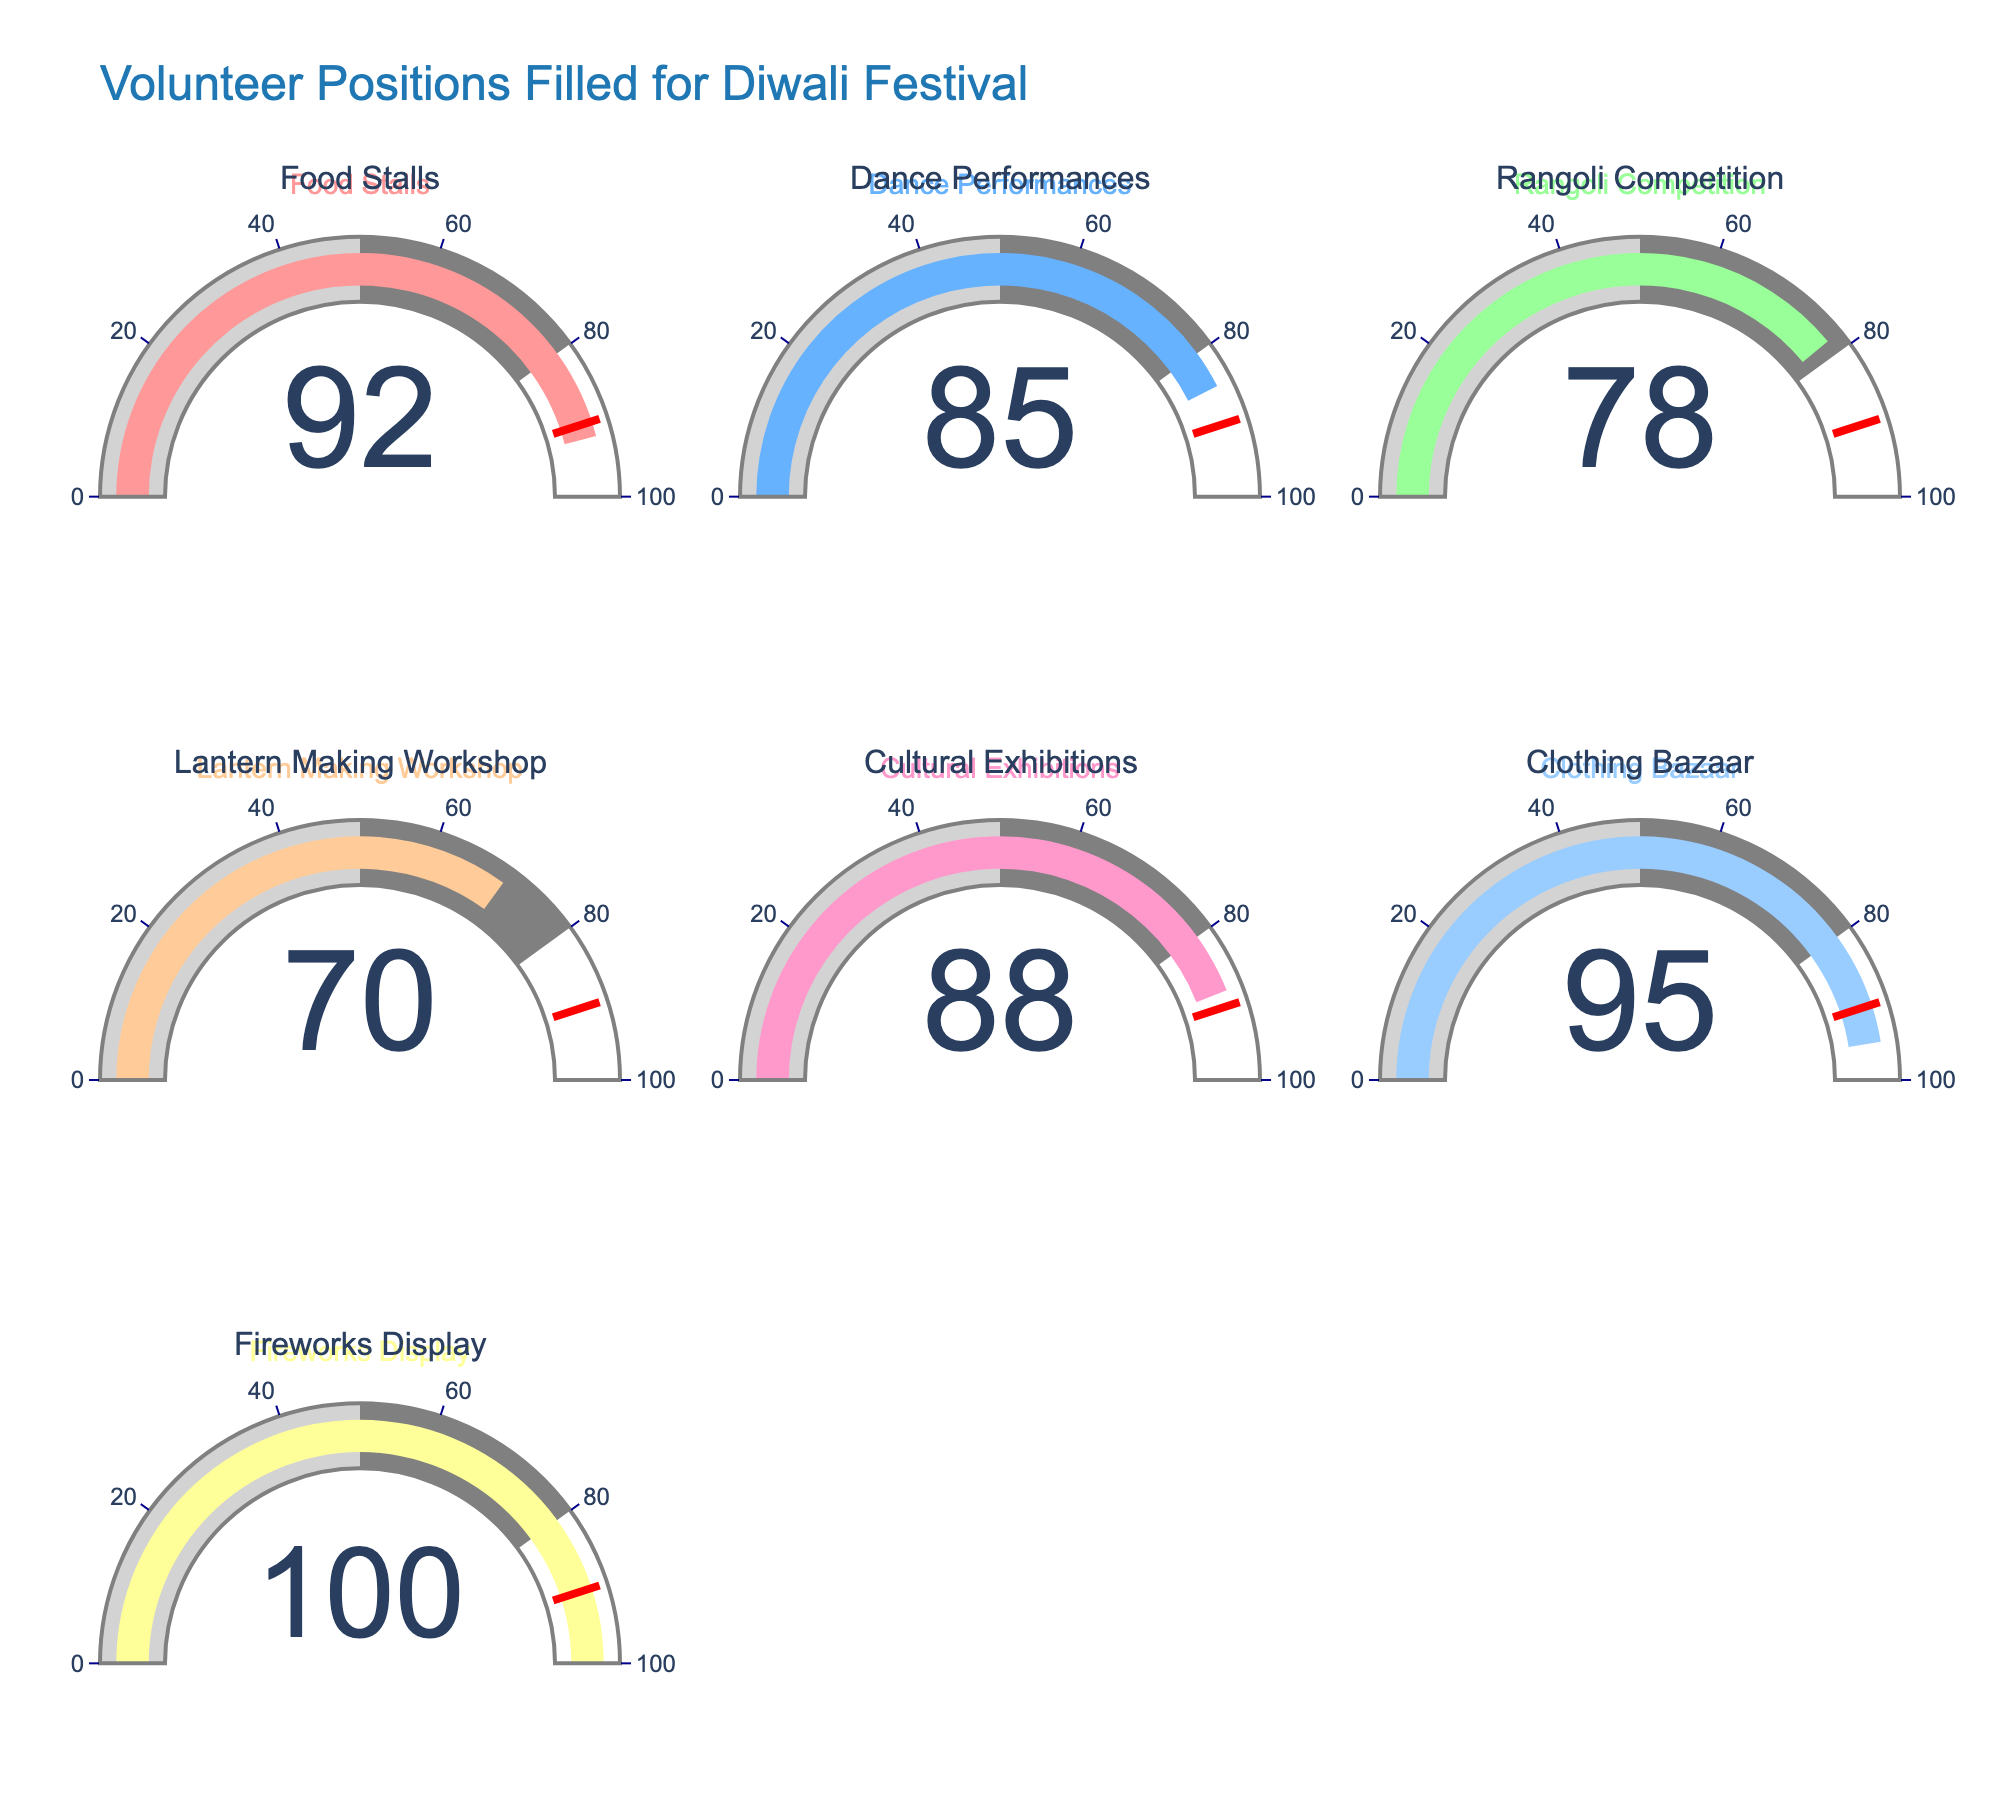What percentage of volunteer positions are filled for the Cultural Exhibitions? The figure shows a gauge for each category. The gauge for Cultural Exhibitions indicates 88%.
Answer: 88% Which event has the highest percentage of volunteer positions filled? By examining each gauge, the Fireworks Display has the highest percentage filled at 100%.
Answer: Fireworks Display What is the total percentage of volunteer positions filled for the Food Stalls and Dance Performances? The percentage for Food Stalls is 92% and for Dance Performances is 85%. Adding them together: 92 + 85 = 177%.
Answer: 177% Are there any events with volunteer positions filled above 90%? If so, which ones? The events with 90% or higher are Food Stalls (92%), Clothing Bazaar (95%), and Fireworks Display (100%).
Answer: Food Stalls, Clothing Bazaar, Fireworks Display What is the average percentage of volunteer positions filled across all categories? Sum all percentages and divide by the number of categories: (92 + 85 + 78 + 70 + 88 + 95 + 100) / 7 = 608/7 ≈ 86.86%.
Answer: 86.86% Is the percentage of filled positions for the Rangoli Competition above or below 80%? The gauge for the Rangoli Competition shows 78%, which is below 80%.
Answer: Below Which category has the lowest percentage of volunteer positions filled? By examining each gauge, Lantern Making Workshop has the lowest percentage at 70%.
Answer: Lantern Making Workshop How many categories have volunteer positions filled above the threshold value of 90%? The gauges showing percentages above 90% are: Food Stalls (92%), Clothing Bazaar (95%), and Fireworks Display (100%), which totals 3 categories.
Answer: 3 